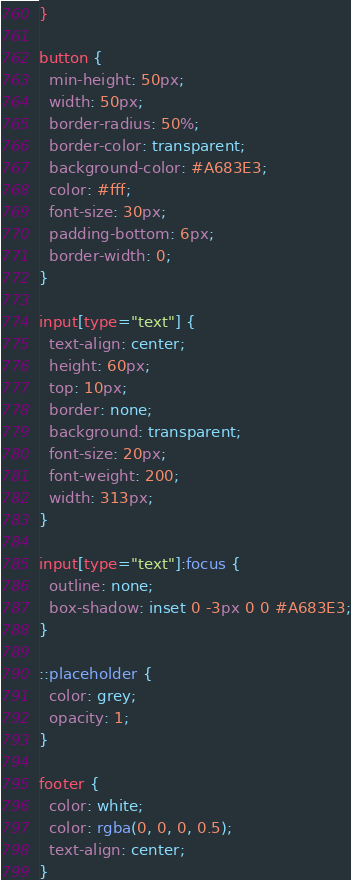<code> <loc_0><loc_0><loc_500><loc_500><_CSS_>}

button {
  min-height: 50px;
  width: 50px;
  border-radius: 50%;
  border-color: transparent;
  background-color: #A683E3;
  color: #fff;
  font-size: 30px;
  padding-bottom: 6px;
  border-width: 0;
}

input[type="text"] {
  text-align: center;
  height: 60px;
  top: 10px;
  border: none;
  background: transparent;
  font-size: 20px;
  font-weight: 200;
  width: 313px;
}

input[type="text"]:focus {
  outline: none;
  box-shadow: inset 0 -3px 0 0 #A683E3;
}

::placeholder {
  color: grey;
  opacity: 1;
}

footer {
  color: white;
  color: rgba(0, 0, 0, 0.5);
  text-align: center;
}
</code> 